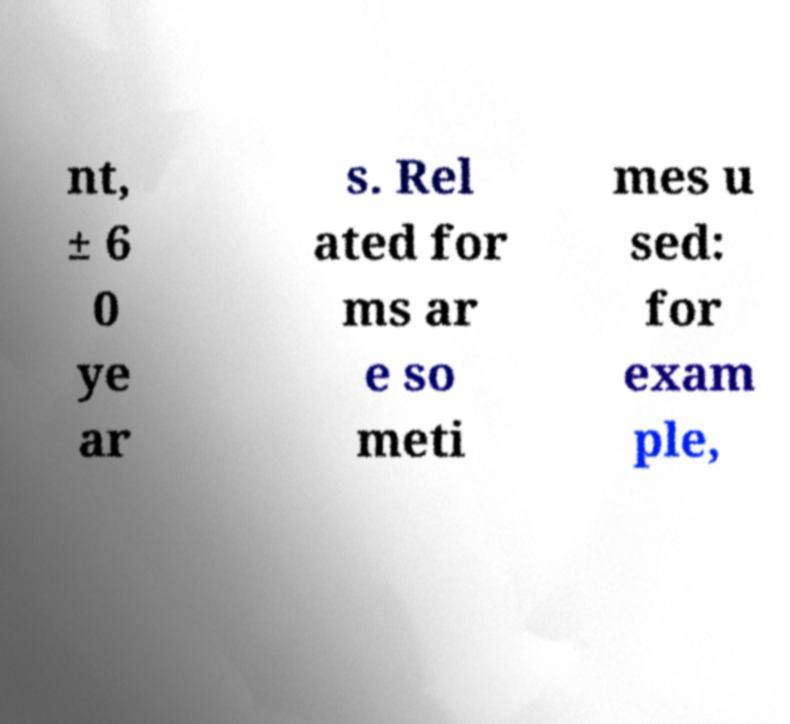I need the written content from this picture converted into text. Can you do that? nt, ± 6 0 ye ar s. Rel ated for ms ar e so meti mes u sed: for exam ple, 